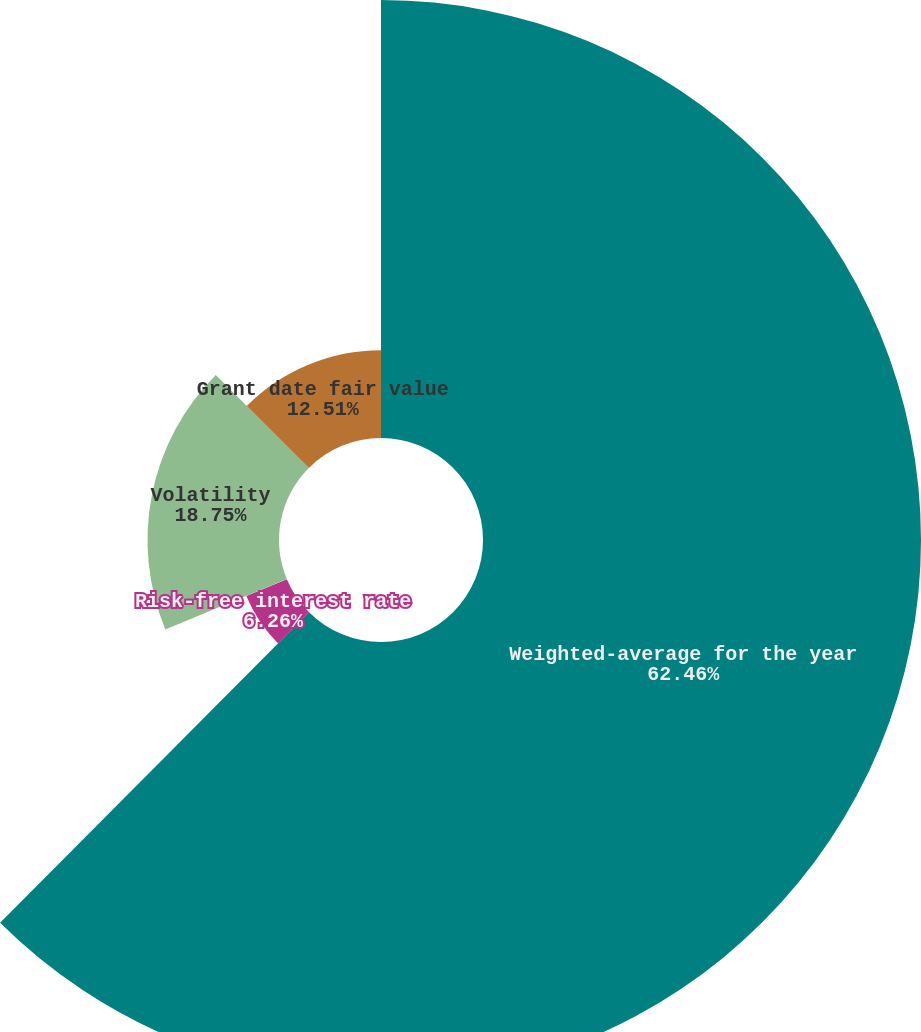<chart> <loc_0><loc_0><loc_500><loc_500><pie_chart><fcel>Weighted-average for the year<fcel>Risk-free interest rate<fcel>Dividend yield<fcel>Volatility<fcel>Grant date fair value<nl><fcel>62.46%<fcel>6.26%<fcel>0.02%<fcel>18.75%<fcel>12.51%<nl></chart> 